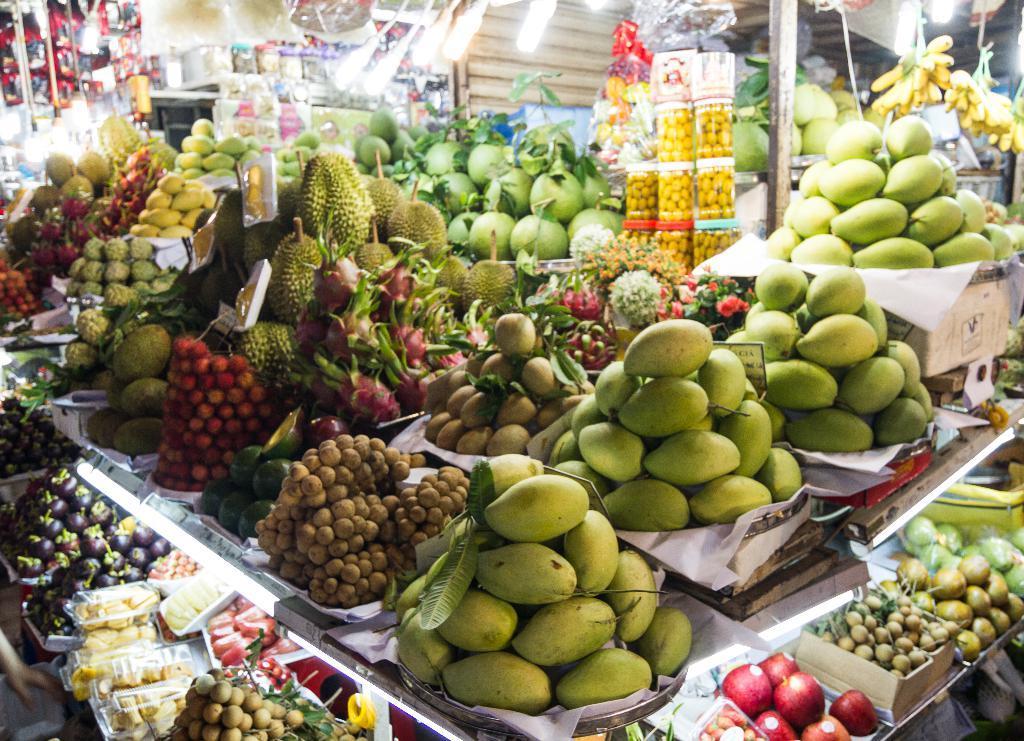Describe this image in one or two sentences. There are different types of fruits are available as we can see in the middle of this image. 